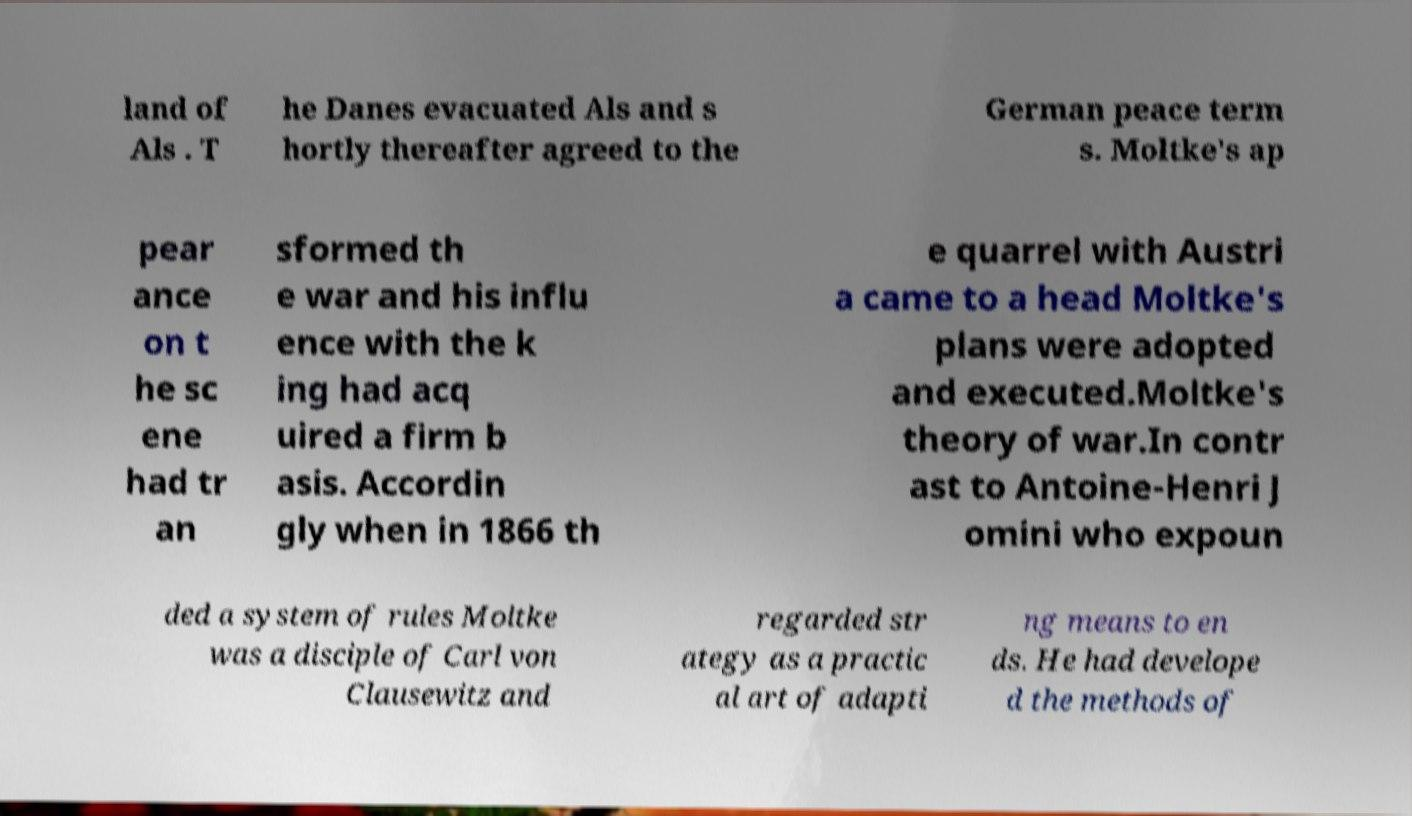Please read and relay the text visible in this image. What does it say? land of Als . T he Danes evacuated Als and s hortly thereafter agreed to the German peace term s. Moltke's ap pear ance on t he sc ene had tr an sformed th e war and his influ ence with the k ing had acq uired a firm b asis. Accordin gly when in 1866 th e quarrel with Austri a came to a head Moltke's plans were adopted and executed.Moltke's theory of war.In contr ast to Antoine-Henri J omini who expoun ded a system of rules Moltke was a disciple of Carl von Clausewitz and regarded str ategy as a practic al art of adapti ng means to en ds. He had develope d the methods of 